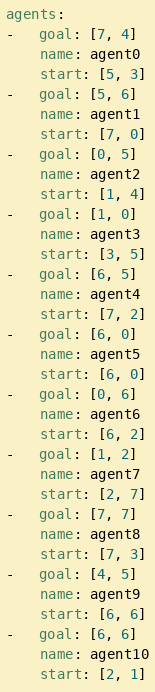Convert code to text. <code><loc_0><loc_0><loc_500><loc_500><_YAML_>agents:
-   goal: [7, 4]
    name: agent0
    start: [5, 3]
-   goal: [5, 6]
    name: agent1
    start: [7, 0]
-   goal: [0, 5]
    name: agent2
    start: [1, 4]
-   goal: [1, 0]
    name: agent3
    start: [3, 5]
-   goal: [6, 5]
    name: agent4
    start: [7, 2]
-   goal: [6, 0]
    name: agent5
    start: [6, 0]
-   goal: [0, 6]
    name: agent6
    start: [6, 2]
-   goal: [1, 2]
    name: agent7
    start: [2, 7]
-   goal: [7, 7]
    name: agent8
    start: [7, 3]
-   goal: [4, 5]
    name: agent9
    start: [6, 6]
-   goal: [6, 6]
    name: agent10
    start: [2, 1]</code> 